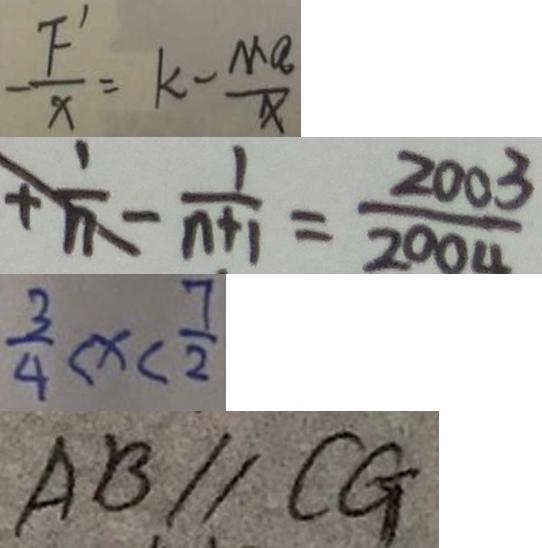<formula> <loc_0><loc_0><loc_500><loc_500>- \frac { F ^ { \prime } } { X } = k - \frac { M a } { x } 
 + \frac { 1 } { n } - \frac { 1 } { n + 1 } = \frac { 2 0 0 3 } { 2 0 0 4 } 
 \frac { 3 } { 4 } < x < \frac { 7 } { 2 } 
 A B / / C G</formula> 